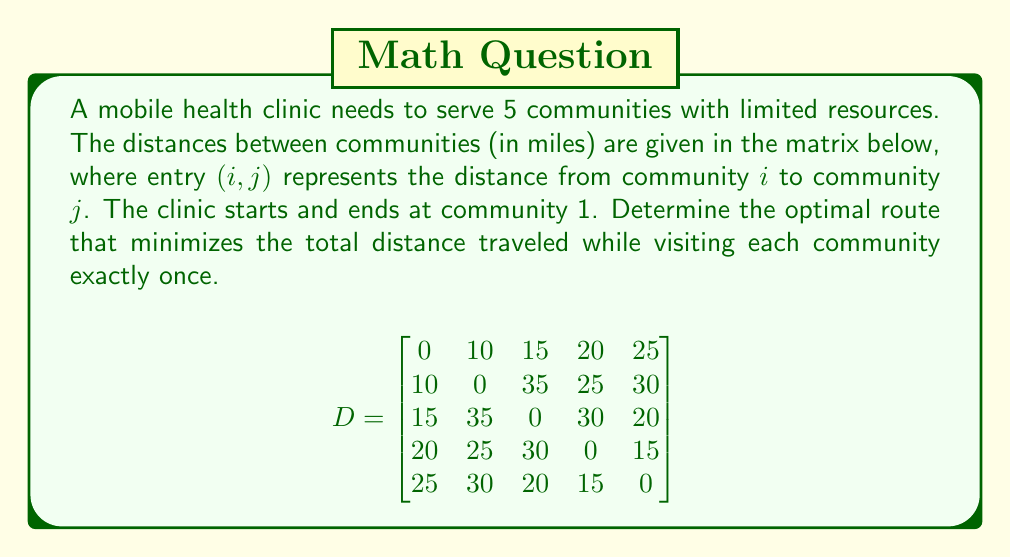Provide a solution to this math problem. To solve this problem, we need to use the Traveling Salesman Problem (TSP) approach. Since we have a small number of communities, we can use a brute-force method to find the optimal route.

Step 1: List all possible routes starting and ending at community 1.
There are $(5-1)! = 24$ possible routes.

Step 2: Calculate the total distance for each route.
For example, route 1-2-3-4-5-1:
Distance = 10 + 35 + 30 + 15 + 25 = 115 miles

Step 3: Compare all routes and find the one with the minimum total distance.

After calculating all routes, we find that the optimal route is:

1-2-4-5-3-1

Step 4: Calculate the total distance for the optimal route:
Distance = 10 (1 to 2) + 25 (2 to 4) + 15 (4 to 5) + 20 (5 to 3) + 15 (3 to 1) = 85 miles

This route minimizes the total distance traveled while visiting each community exactly once.
Answer: 1-2-4-5-3-1, 85 miles 